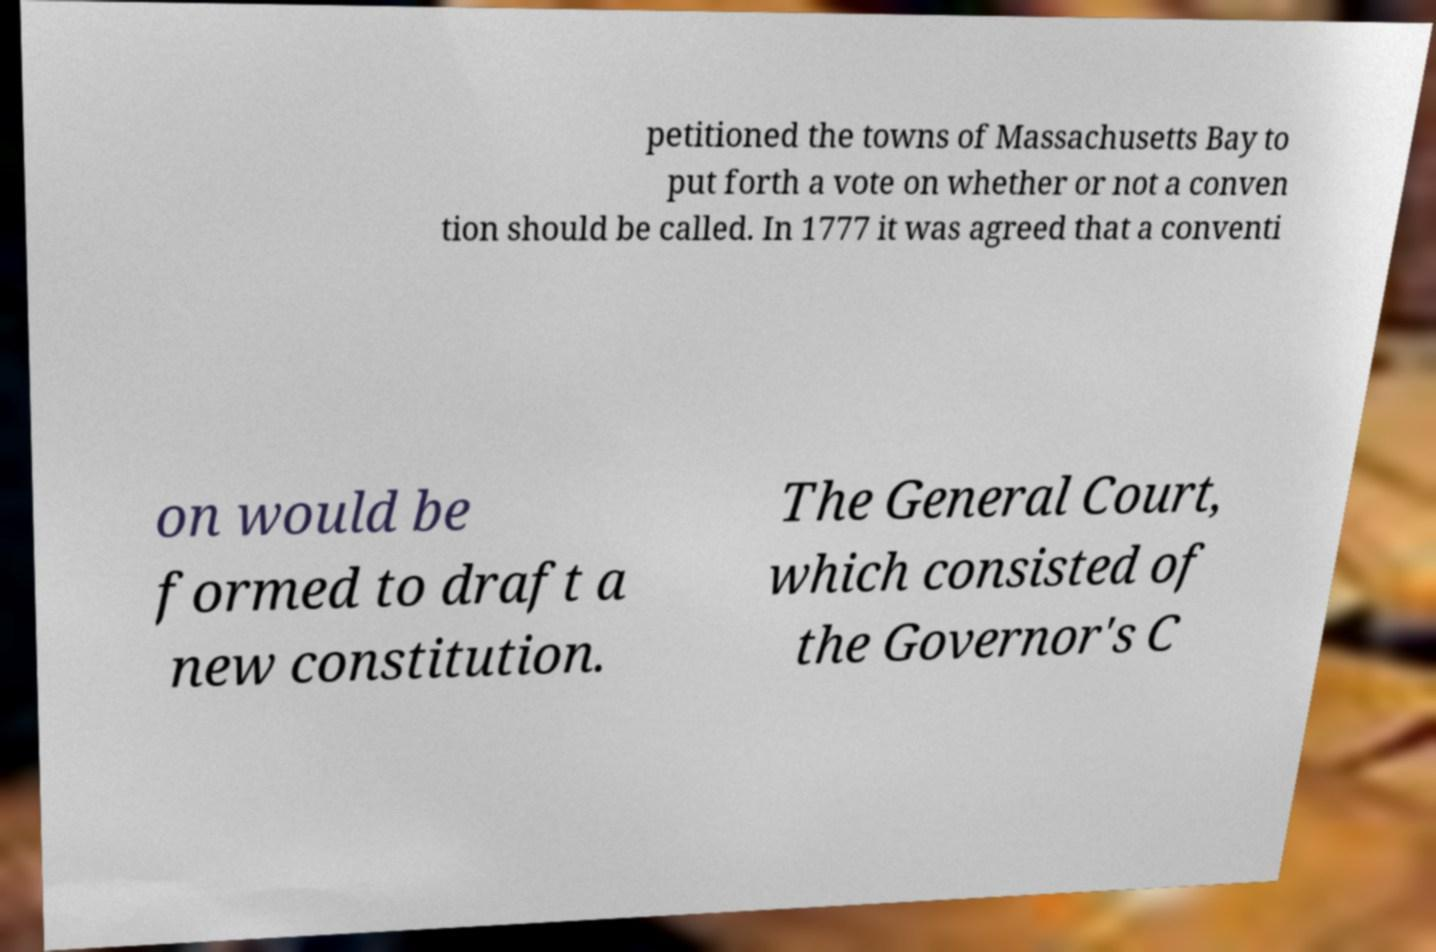Can you accurately transcribe the text from the provided image for me? petitioned the towns of Massachusetts Bay to put forth a vote on whether or not a conven tion should be called. In 1777 it was agreed that a conventi on would be formed to draft a new constitution. The General Court, which consisted of the Governor's C 